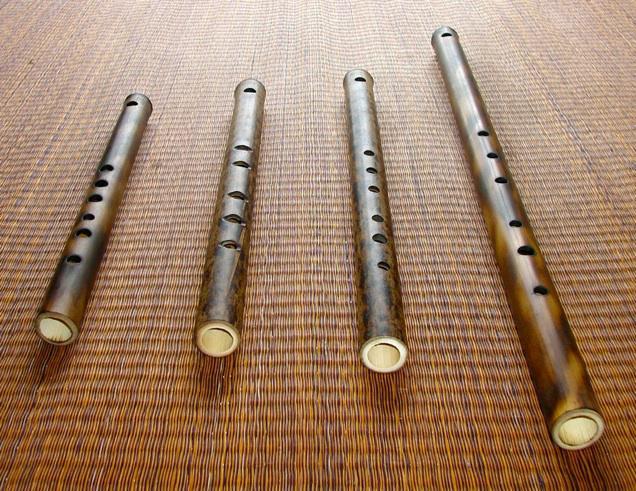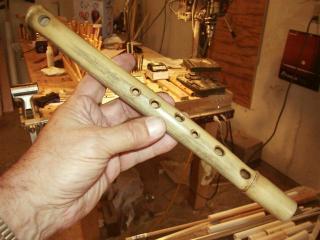The first image is the image on the left, the second image is the image on the right. For the images shown, is this caption "There are three flutes in total." true? Answer yes or no. No. The first image is the image on the left, the second image is the image on the right. For the images displayed, is the sentence "One image contains a single flute displayed diagonally, and the other image contains two items displayed horizontally, at least one a bamboo stick without a row of small holes on it." factually correct? Answer yes or no. No. 